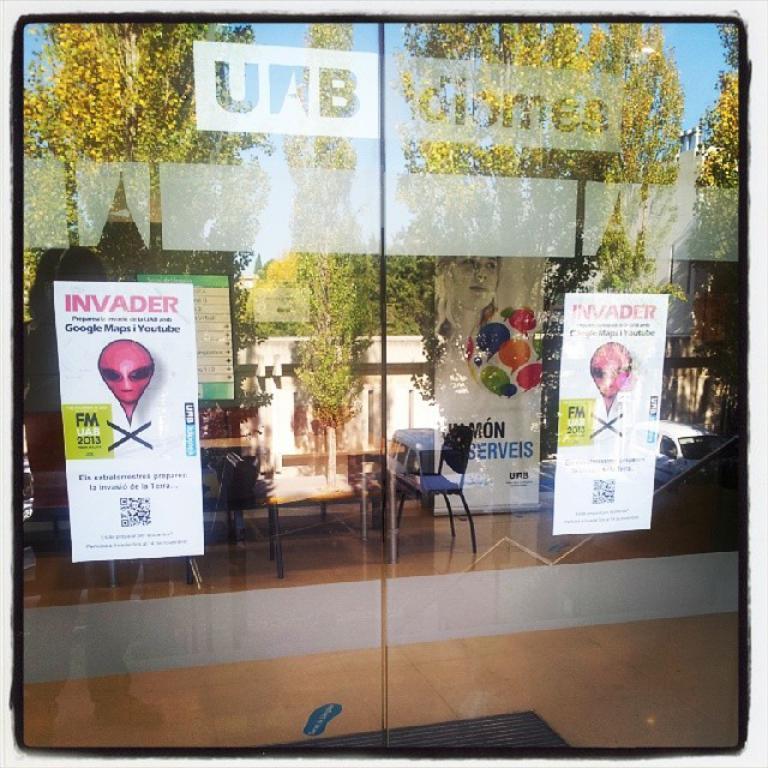Describe this image in one or two sentences. In this image two pictures are attached to the glass doors. Behind there are few chairs and tables. On glass door there is a reflection of few vehicles. Behind there is a wall. Behind it there are few trees and sky. Left side of image there is a reflection of a person standing on the floor. 